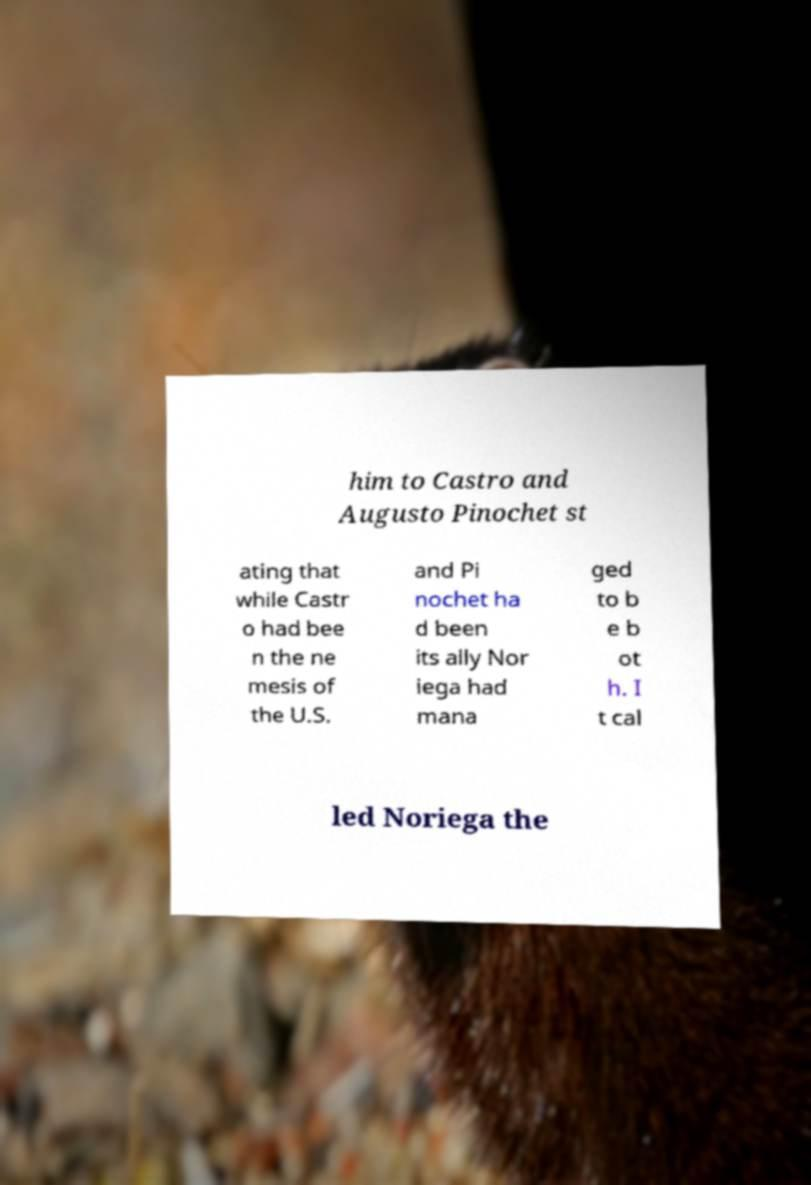I need the written content from this picture converted into text. Can you do that? him to Castro and Augusto Pinochet st ating that while Castr o had bee n the ne mesis of the U.S. and Pi nochet ha d been its ally Nor iega had mana ged to b e b ot h. I t cal led Noriega the 